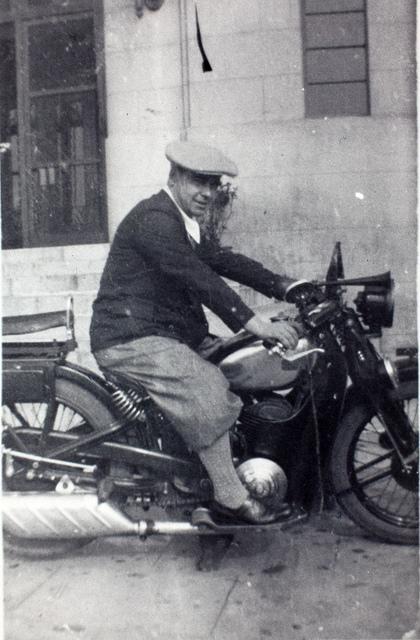Does the rider have on a proper helmet?
Quick response, please. No. What is the person sitting on?
Keep it brief. Motorcycle. Is this a current photograph?
Write a very short answer. No. 